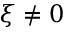Convert formula to latex. <formula><loc_0><loc_0><loc_500><loc_500>\xi \neq 0</formula> 